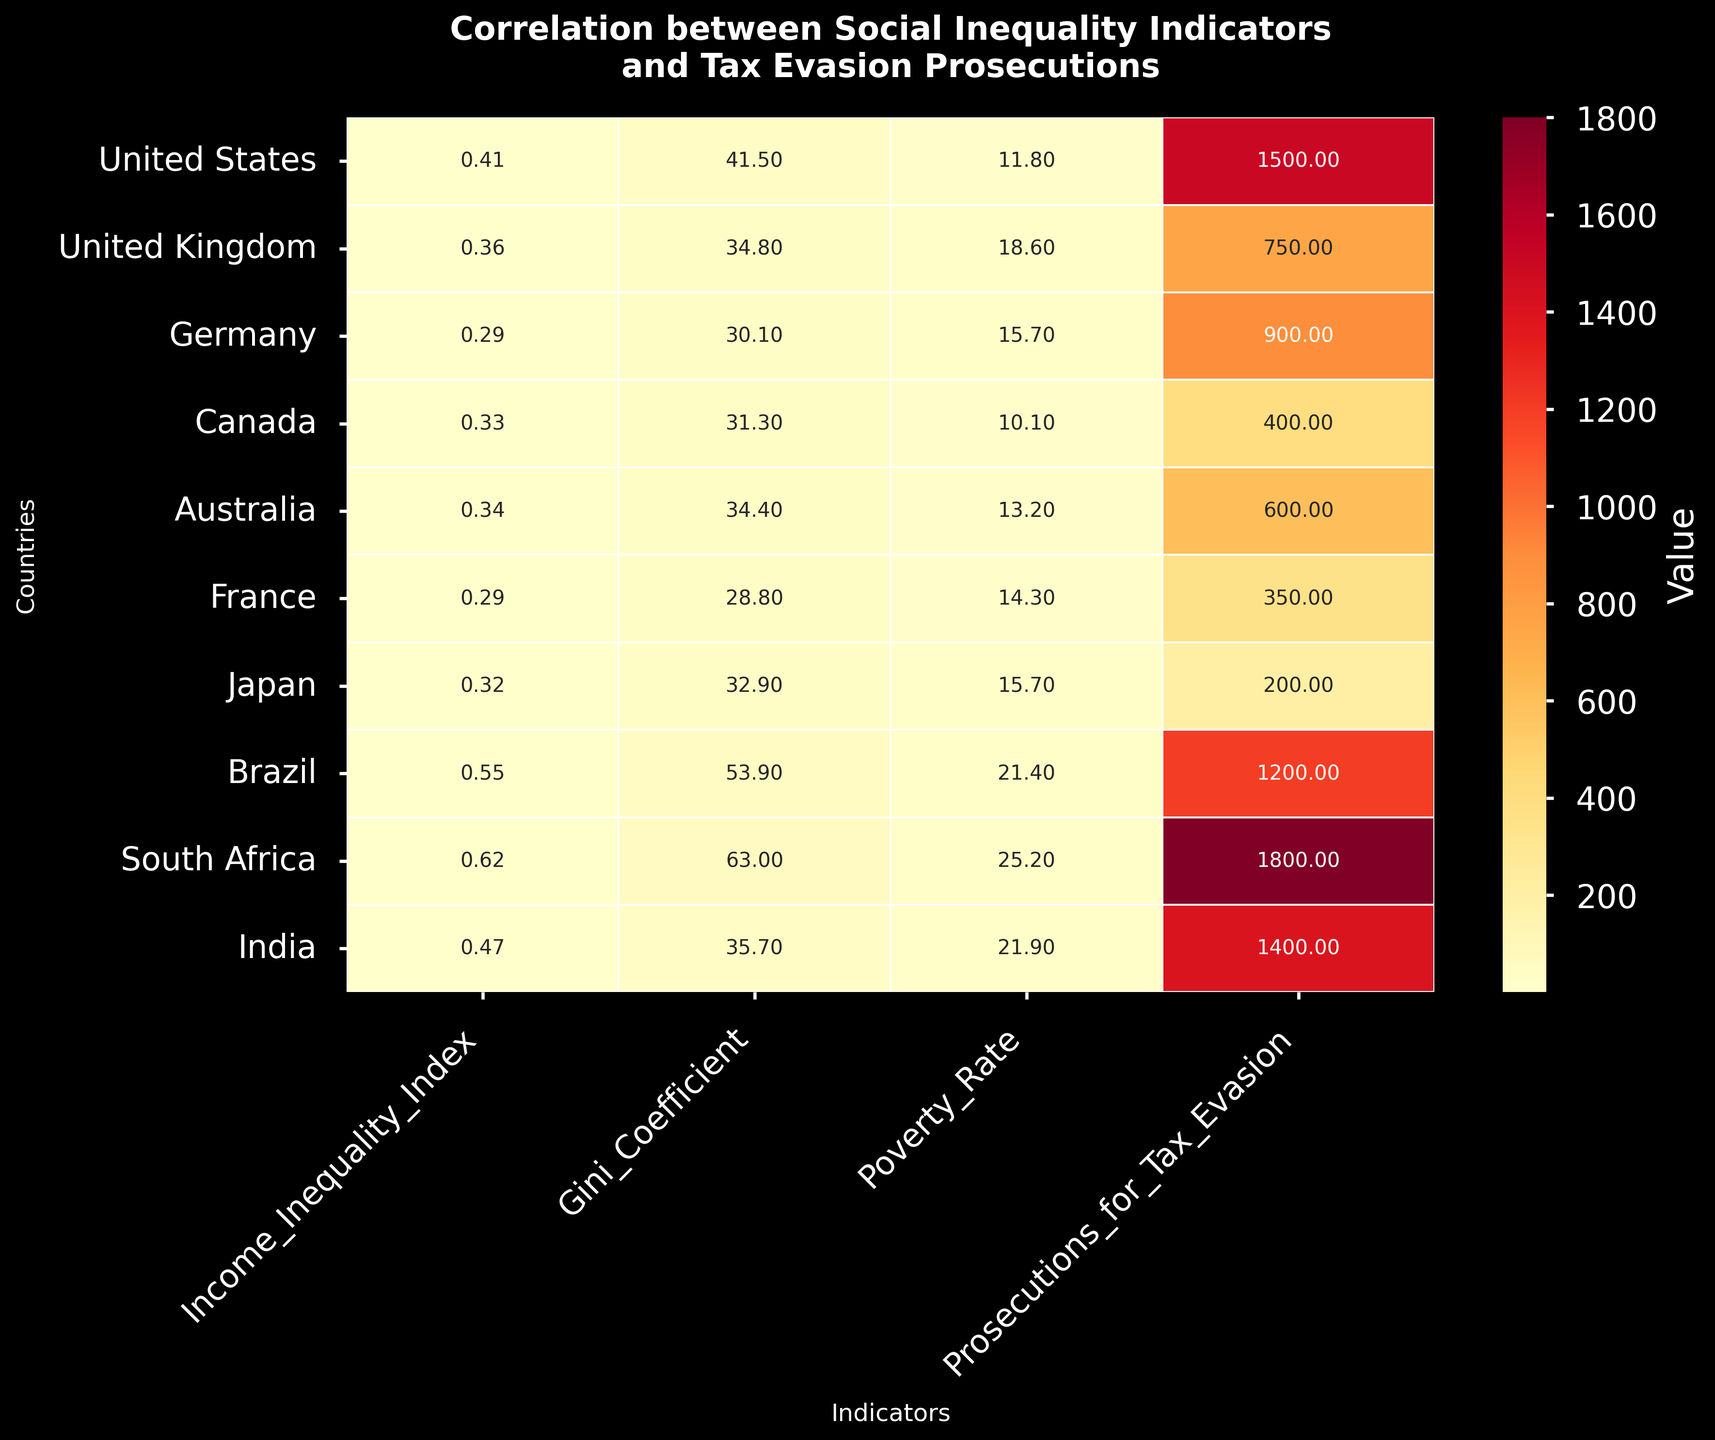What's the title of the heatmap? The title is usually placed at the top of the figure. In this case, it's clearly written at the top of the heatmap.
Answer: Correlation between Social Inequality Indicators and Tax Evasion Prosecutions How many countries' data are included in the heatmap? By counting the number of rows, each representing a different country, we can see the total number of countries.
Answer: 10 Which country has the highest number of prosecutions for tax evasion? Look for the highest value in the column "Prosecutions_for_Tax_Evasion". South Africa has the highest number, which is 1800.
Answer: South Africa What is the Gini Coefficient for Brazil? Find the row corresponding to Brazil and the column titled "Gini_Coefficient." The value for Brazil is 53.9.
Answer: 53.9 Which country shows the lowest level of income inequality according to the Income Inequality Index? Identify the smallest number in the "Income_Inequality_Index" column. France has the lowest value, which is 0.29.
Answer: France Compare the poverty rates in the United States and the United Kingdom. Which one is higher? Find the values in the "Poverty_Rate" column for the United States (11.8) and the United Kingdom (18.6). The United Kingdom has a higher poverty rate.
Answer: United Kingdom What is the average Poverty Rate across all countries? Adding up all values in the "Poverty_Rate" column (11.8 + 18.6 + 15.7 + 10.1 + 13.2 + 14.3 + 15.7 + 21.4 + 25.2 + 21.9) gives a sum of 168.9. Dividing this by the number of countries (10) gives an average of 16.89.
Answer: 16.89 Is there a country with a higher Poverty Rate than South Africa? South Africa has the highest poverty rate of 25.2, as observed from the highest value in the "Poverty_Rate" column. No other country surpasses this value.
Answer: No What's the correlation between the Income Inequality Index and Gini Coefficient for India? Are they positively correlated? For India, both metrics (Income Inequality Index of 0.47 and Gini Coefficient of 35.7) should be examined in context. Both increase together suggesting a positive correlation.
Answer: Yes 